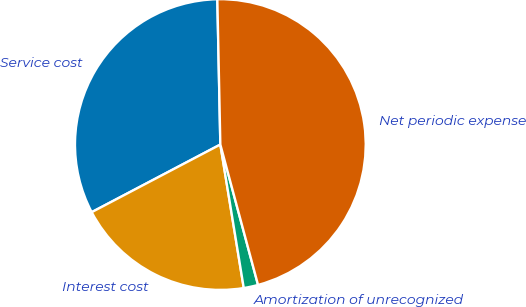Convert chart to OTSL. <chart><loc_0><loc_0><loc_500><loc_500><pie_chart><fcel>Service cost<fcel>Interest cost<fcel>Amortization of unrecognized<fcel>Net periodic expense<nl><fcel>32.37%<fcel>19.87%<fcel>1.6%<fcel>46.15%<nl></chart> 